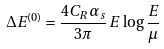<formula> <loc_0><loc_0><loc_500><loc_500>\Delta E ^ { ( 0 ) } = \frac { 4 C _ { R } \alpha _ { s } } { 3 \pi } \, E \, \log \frac { E } { \mu }</formula> 